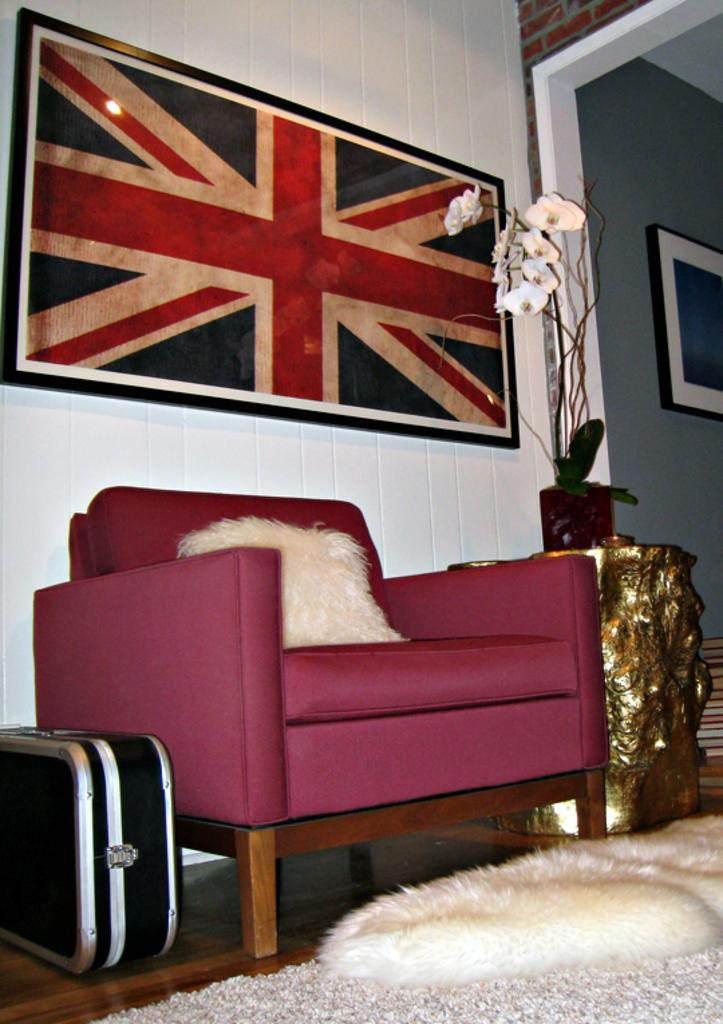What color is the sofa in the image? The sofa in the image is red. What is placed on the sofa? There is a pillow on the sofa. What is the color of the desk beside the sofa? The desk is golden in color. What can be found on the desk? There is a flower vase on the desk. What is in front of the desk? There is a floor mat in front of the desk. How many minutes does the son take to water the stem in the image? There is no son or stem present in the image. What type of stem is visible in the image? There is no stem present in the image. 